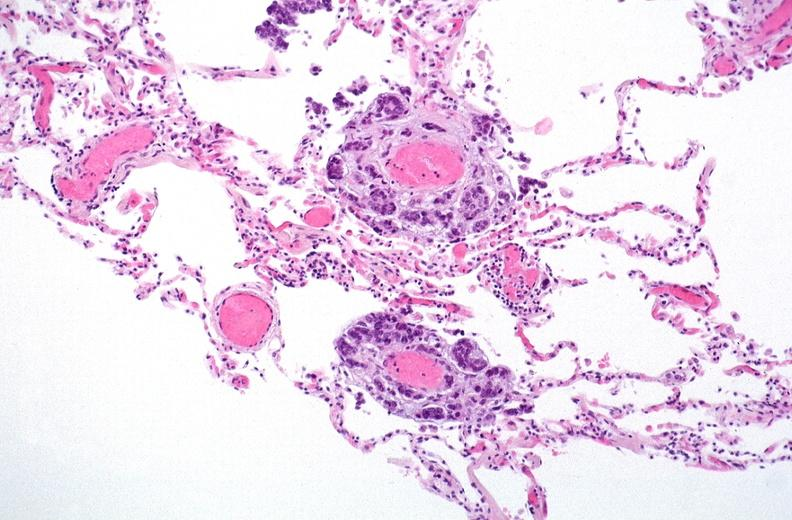s respiratory present?
Answer the question using a single word or phrase. Yes 